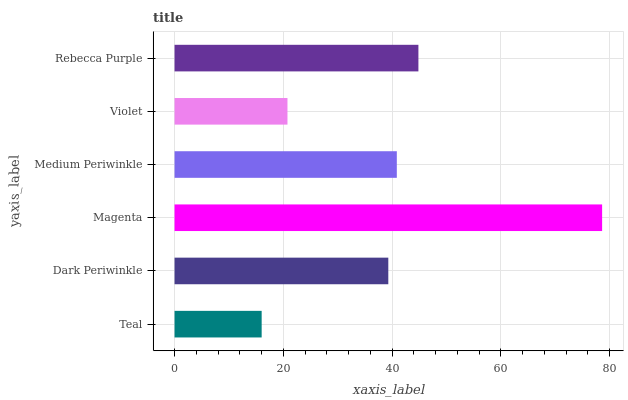Is Teal the minimum?
Answer yes or no. Yes. Is Magenta the maximum?
Answer yes or no. Yes. Is Dark Periwinkle the minimum?
Answer yes or no. No. Is Dark Periwinkle the maximum?
Answer yes or no. No. Is Dark Periwinkle greater than Teal?
Answer yes or no. Yes. Is Teal less than Dark Periwinkle?
Answer yes or no. Yes. Is Teal greater than Dark Periwinkle?
Answer yes or no. No. Is Dark Periwinkle less than Teal?
Answer yes or no. No. Is Medium Periwinkle the high median?
Answer yes or no. Yes. Is Dark Periwinkle the low median?
Answer yes or no. Yes. Is Teal the high median?
Answer yes or no. No. Is Violet the low median?
Answer yes or no. No. 